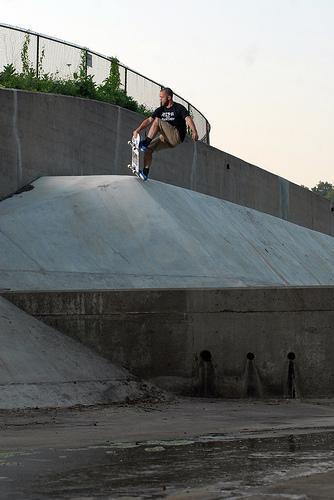How many skaters are there?
Give a very brief answer. 1. 